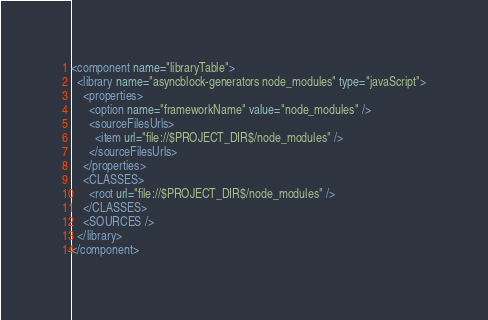Convert code to text. <code><loc_0><loc_0><loc_500><loc_500><_XML_><component name="libraryTable">
  <library name="asyncblock-generators node_modules" type="javaScript">
    <properties>
      <option name="frameworkName" value="node_modules" />
      <sourceFilesUrls>
        <item url="file://$PROJECT_DIR$/node_modules" />
      </sourceFilesUrls>
    </properties>
    <CLASSES>
      <root url="file://$PROJECT_DIR$/node_modules" />
    </CLASSES>
    <SOURCES />
  </library>
</component></code> 